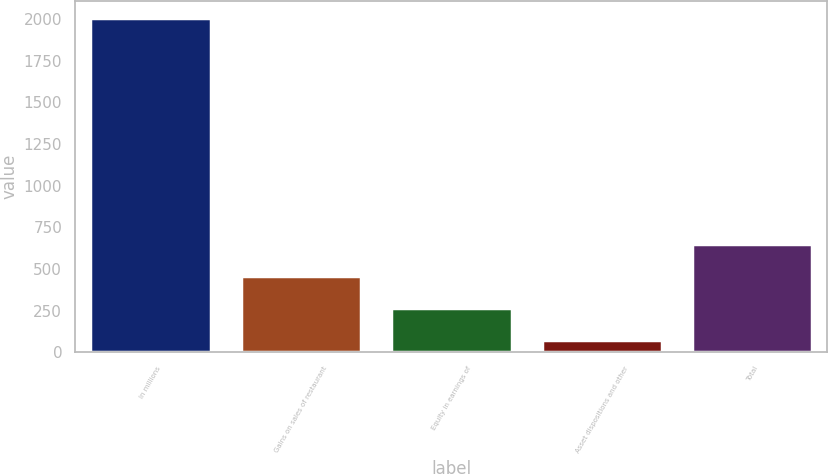Convert chart. <chart><loc_0><loc_0><loc_500><loc_500><bar_chart><fcel>In millions<fcel>Gains on sales of restaurant<fcel>Equity in earnings of<fcel>Asset dispositions and other<fcel>Total<nl><fcel>2008<fcel>459.2<fcel>265.6<fcel>72<fcel>652.8<nl></chart> 